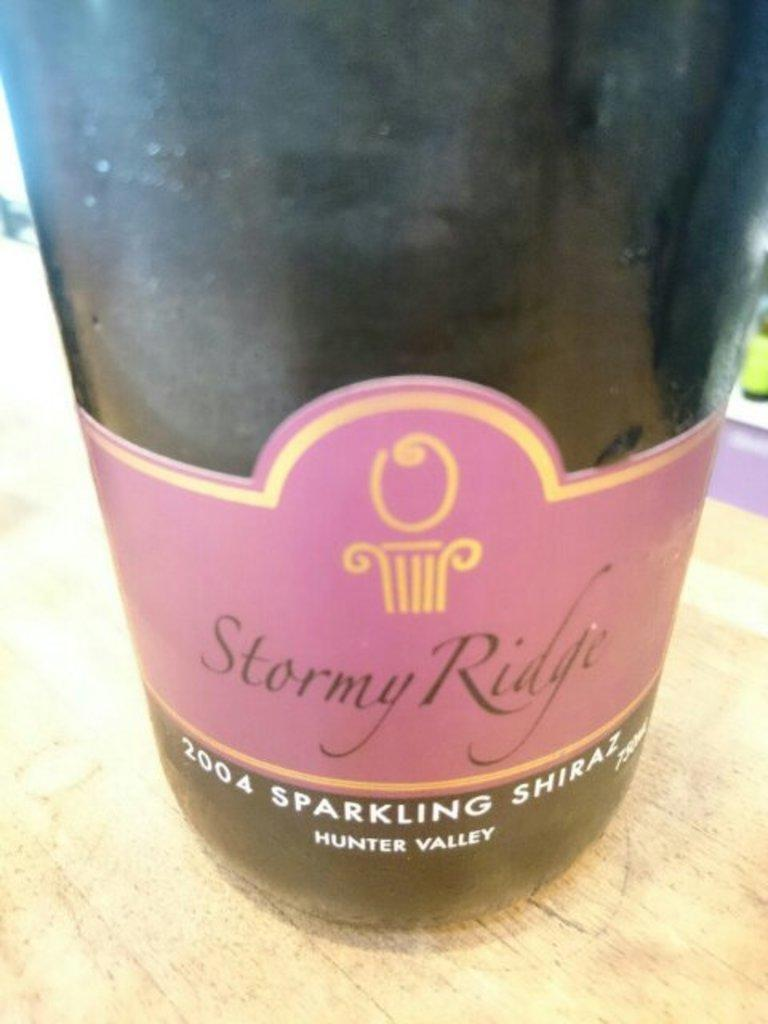Provide a one-sentence caption for the provided image. A bottle of 2004 Sparkling Shiraz from Stormy Ridge. 